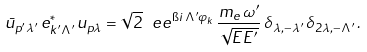<formula> <loc_0><loc_0><loc_500><loc_500>\bar { u } _ { p ^ { \prime } \lambda ^ { \prime } } \, e _ { k ^ { \prime } \Lambda ^ { \prime } } ^ { * } \, u _ { p \lambda } = \sqrt { 2 } \, \ e e ^ { \i i \, \Lambda ^ { \prime } \varphi _ { k } } \, \frac { m _ { e } \, \omega ^ { \prime } } { \sqrt { E E ^ { \prime } } } \, \delta _ { \lambda , - \lambda ^ { \prime } } \, \delta _ { 2 \lambda , - \Lambda ^ { \prime } } \, .</formula> 